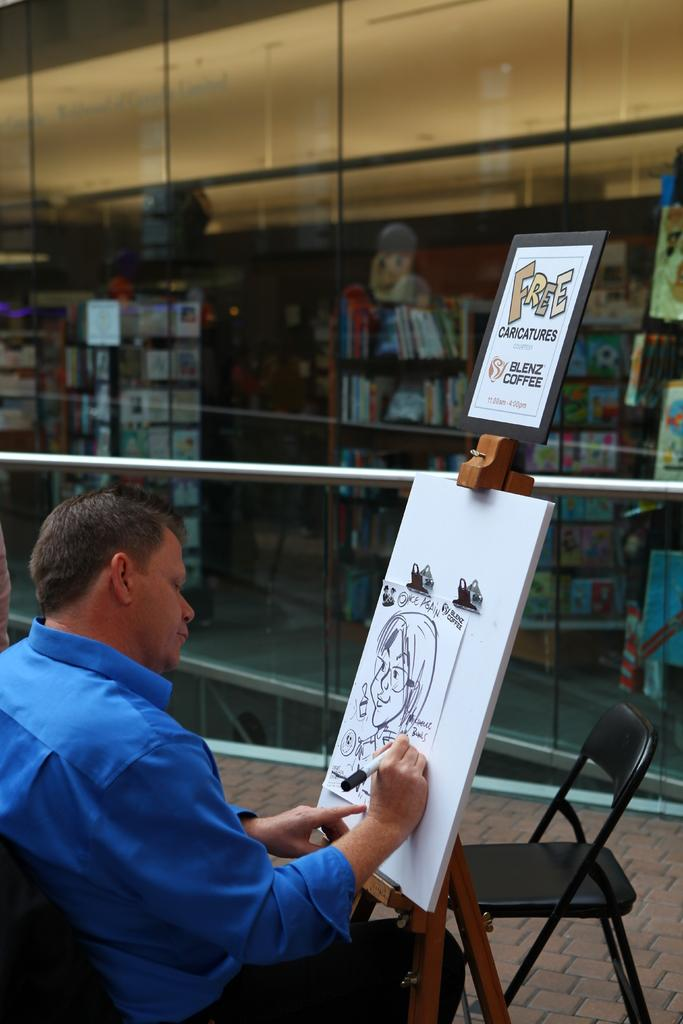Who is the main subject in the image? There is a man in the image. What is the man doing in the image? The man is sitting and drawing a picture. What is the man using to draw the picture? The man is using an artist pad. What type of carriage can be seen in the image? There is no carriage present in the image; it features a man sitting and drawing a picture. How does the egg affect the man's drawing in the image? There is no egg present in the image, so it cannot affect the man's drawing. 